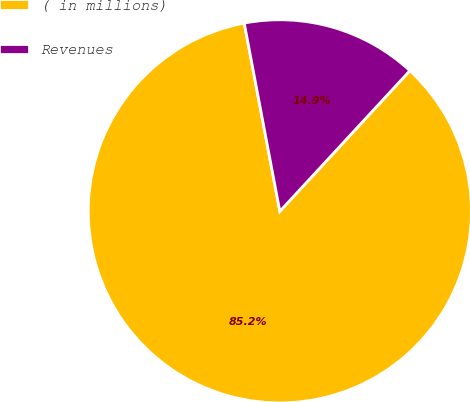Convert chart to OTSL. <chart><loc_0><loc_0><loc_500><loc_500><pie_chart><fcel>( in millions)<fcel>Revenues<nl><fcel>85.15%<fcel>14.85%<nl></chart> 